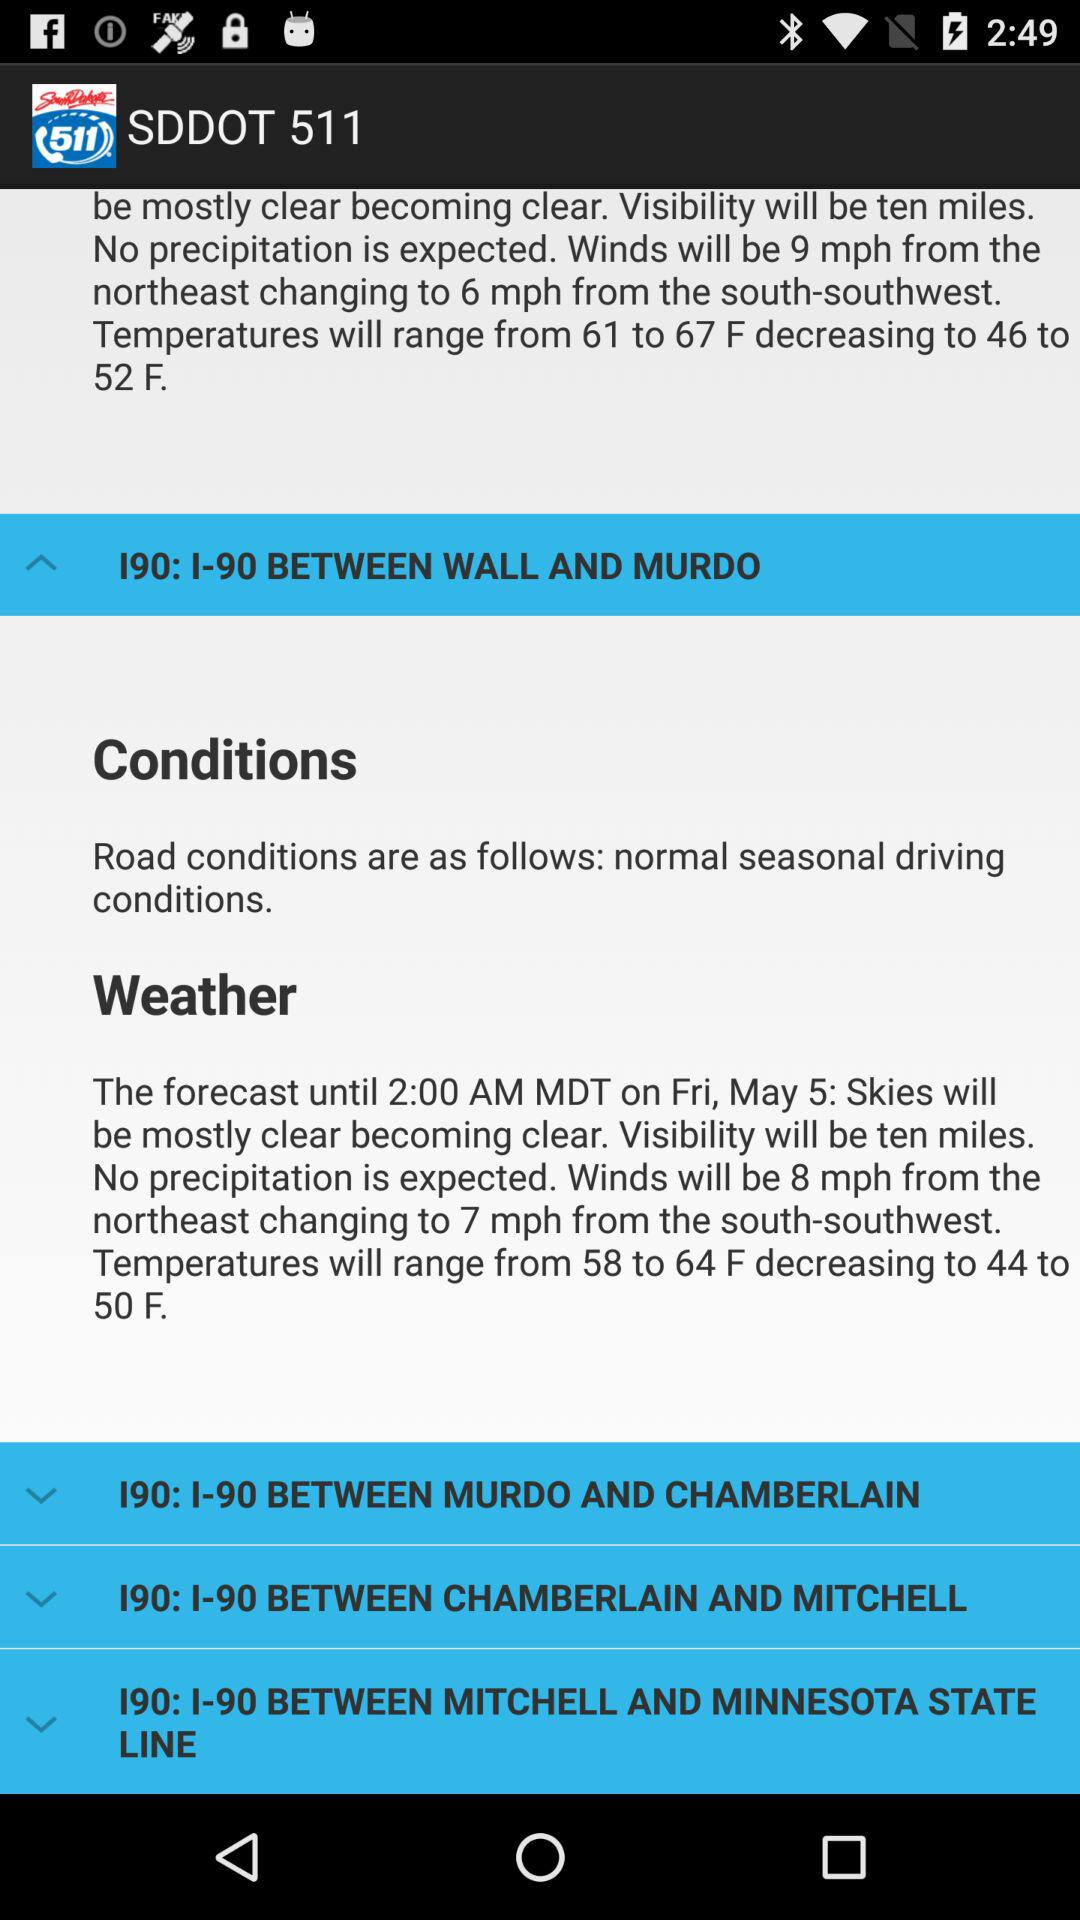What are the road conditions? The road conditions are normal seasonal driving. 